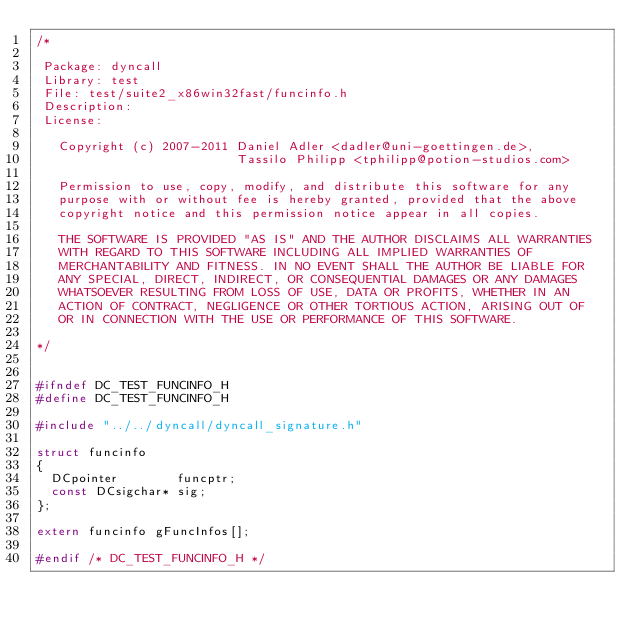Convert code to text. <code><loc_0><loc_0><loc_500><loc_500><_C_>/*

 Package: dyncall
 Library: test
 File: test/suite2_x86win32fast/funcinfo.h
 Description: 
 License:

   Copyright (c) 2007-2011 Daniel Adler <dadler@uni-goettingen.de>, 
                           Tassilo Philipp <tphilipp@potion-studios.com>

   Permission to use, copy, modify, and distribute this software for any
   purpose with or without fee is hereby granted, provided that the above
   copyright notice and this permission notice appear in all copies.

   THE SOFTWARE IS PROVIDED "AS IS" AND THE AUTHOR DISCLAIMS ALL WARRANTIES
   WITH REGARD TO THIS SOFTWARE INCLUDING ALL IMPLIED WARRANTIES OF
   MERCHANTABILITY AND FITNESS. IN NO EVENT SHALL THE AUTHOR BE LIABLE FOR
   ANY SPECIAL, DIRECT, INDIRECT, OR CONSEQUENTIAL DAMAGES OR ANY DAMAGES
   WHATSOEVER RESULTING FROM LOSS OF USE, DATA OR PROFITS, WHETHER IN AN
   ACTION OF CONTRACT, NEGLIGENCE OR OTHER TORTIOUS ACTION, ARISING OUT OF
   OR IN CONNECTION WITH THE USE OR PERFORMANCE OF THIS SOFTWARE.

*/


#ifndef DC_TEST_FUNCINFO_H
#define DC_TEST_FUNCINFO_H

#include "../../dyncall/dyncall_signature.h"

struct funcinfo
{
  DCpointer        funcptr;
  const DCsigchar* sig;
};

extern funcinfo gFuncInfos[];

#endif /* DC_TEST_FUNCINFO_H */



</code> 